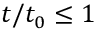Convert formula to latex. <formula><loc_0><loc_0><loc_500><loc_500>t / t _ { 0 } \leq 1</formula> 